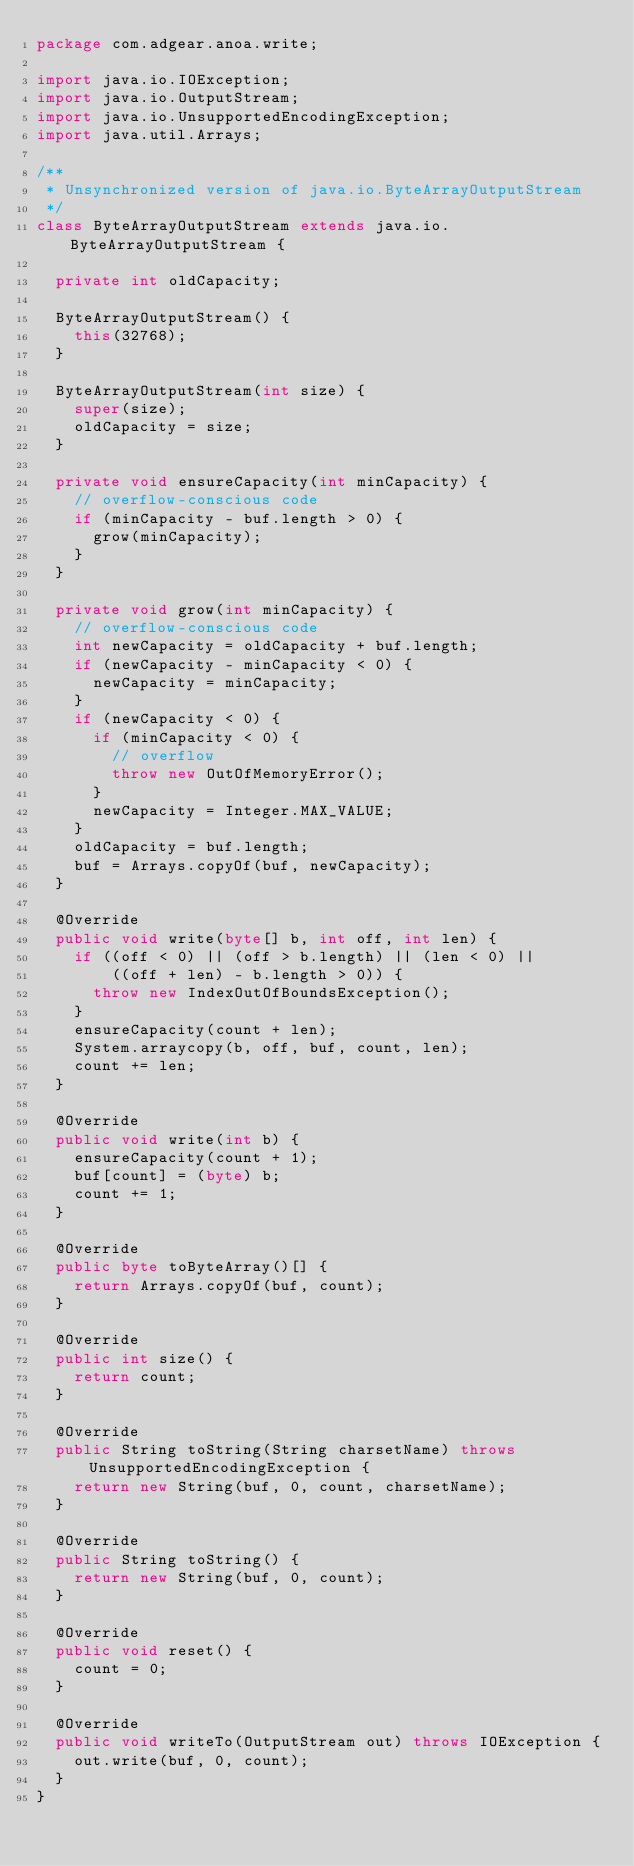Convert code to text. <code><loc_0><loc_0><loc_500><loc_500><_Java_>package com.adgear.anoa.write;

import java.io.IOException;
import java.io.OutputStream;
import java.io.UnsupportedEncodingException;
import java.util.Arrays;

/**
 * Unsynchronized version of java.io.ByteArrayOutputStream
 */
class ByteArrayOutputStream extends java.io.ByteArrayOutputStream {

  private int oldCapacity;

  ByteArrayOutputStream() {
    this(32768);
  }

  ByteArrayOutputStream(int size) {
    super(size);
    oldCapacity = size;
  }

  private void ensureCapacity(int minCapacity) {
    // overflow-conscious code
    if (minCapacity - buf.length > 0) {
      grow(minCapacity);
    }
  }

  private void grow(int minCapacity) {
    // overflow-conscious code
    int newCapacity = oldCapacity + buf.length;
    if (newCapacity - minCapacity < 0) {
      newCapacity = minCapacity;
    }
    if (newCapacity < 0) {
      if (minCapacity < 0) {
        // overflow
        throw new OutOfMemoryError();
      }
      newCapacity = Integer.MAX_VALUE;
    }
    oldCapacity = buf.length;
    buf = Arrays.copyOf(buf, newCapacity);
  }

  @Override
  public void write(byte[] b, int off, int len) {
    if ((off < 0) || (off > b.length) || (len < 0) ||
        ((off + len) - b.length > 0)) {
      throw new IndexOutOfBoundsException();
    }
    ensureCapacity(count + len);
    System.arraycopy(b, off, buf, count, len);
    count += len;
  }

  @Override
  public void write(int b) {
    ensureCapacity(count + 1);
    buf[count] = (byte) b;
    count += 1;
  }

  @Override
  public byte toByteArray()[] {
    return Arrays.copyOf(buf, count);
  }

  @Override
  public int size() {
    return count;
  }

  @Override
  public String toString(String charsetName) throws UnsupportedEncodingException {
    return new String(buf, 0, count, charsetName);
  }

  @Override
  public String toString() {
    return new String(buf, 0, count);
  }

  @Override
  public void reset() {
    count = 0;
  }

  @Override
  public void writeTo(OutputStream out) throws IOException {
    out.write(buf, 0, count);
  }
}
</code> 